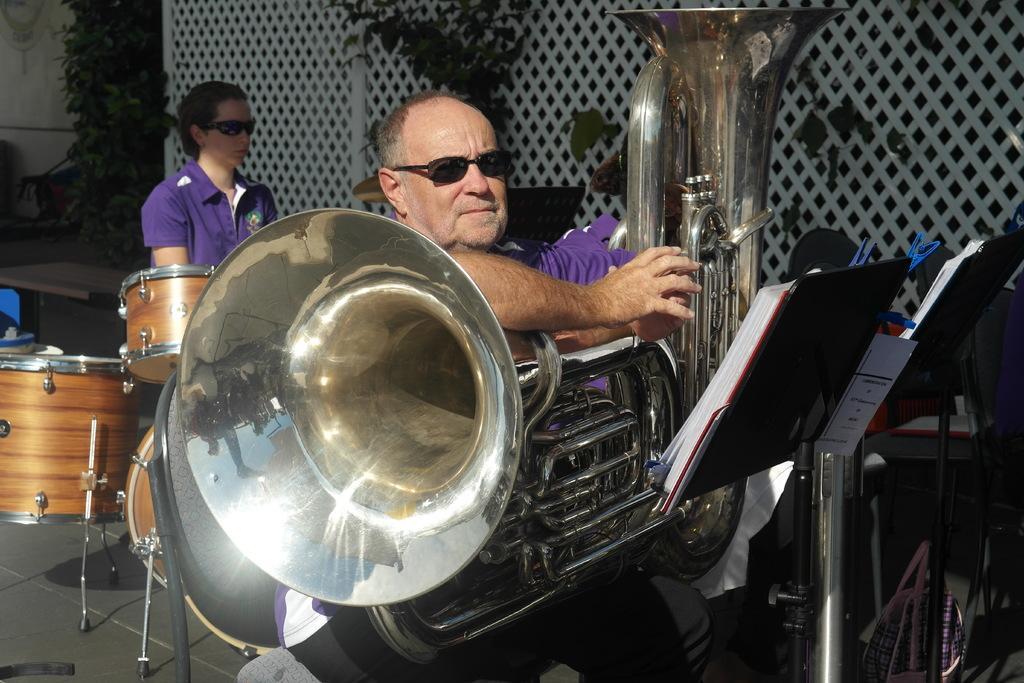How would you summarize this image in a sentence or two? In this image I can see two persons. In front the person is wearing purple color shirt and I can also see few musical instruments, two books on the stands. In the background I can see few plants in green color. 